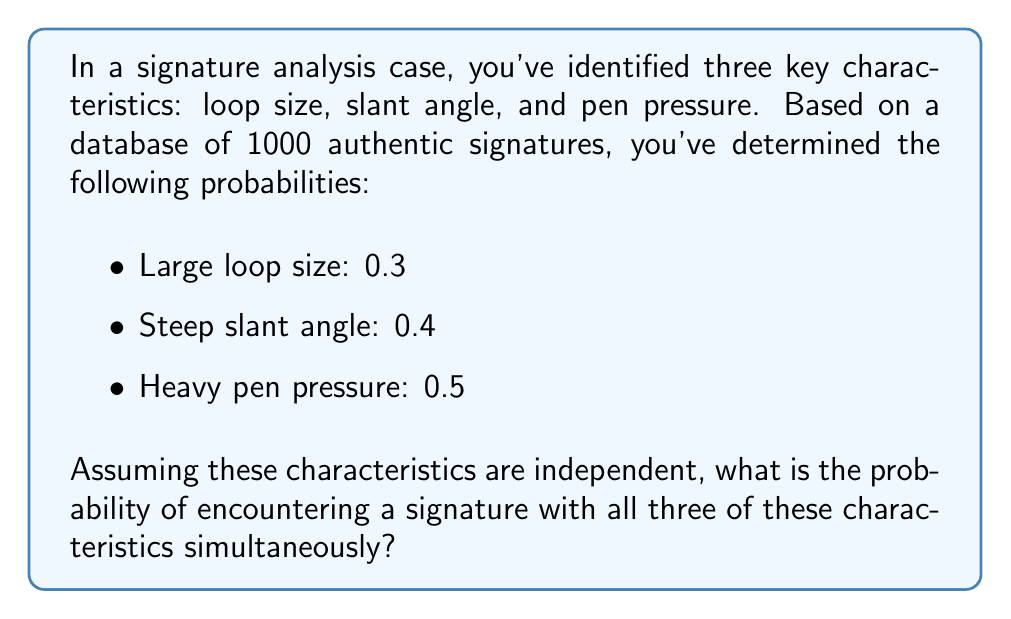Show me your answer to this math problem. To solve this problem, we need to use the multiplication rule for independent events. Since the characteristics are assumed to be independent, we can multiply their individual probabilities to find the probability of all three occurring together.

Let's define our events:
$A$: Large loop size
$B$: Steep slant angle
$C$: Heavy pen pressure

We're given:
$P(A) = 0.3$
$P(B) = 0.4$
$P(C) = 0.5$

The probability of all three characteristics occurring together is:

$$P(A \cap B \cap C) = P(A) \times P(B) \times P(C)$$

Substituting the values:

$$P(A \cap B \cap C) = 0.3 \times 0.4 \times 0.5$$

Calculating:

$$P(A \cap B \cap C) = 0.06$$

Therefore, the probability of encountering a signature with all three of these characteristics simultaneously is 0.06 or 6%.
Answer: 0.06 